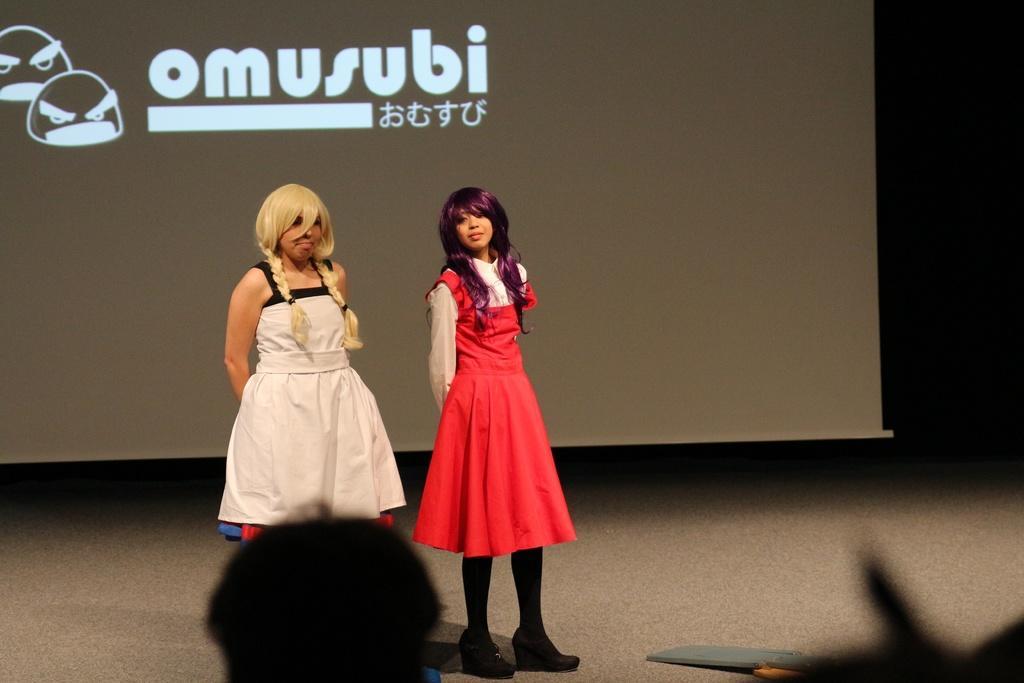Can you describe this image briefly? In this picture I can observe two women standing on the floor. In the background I can observe projector display screen. 